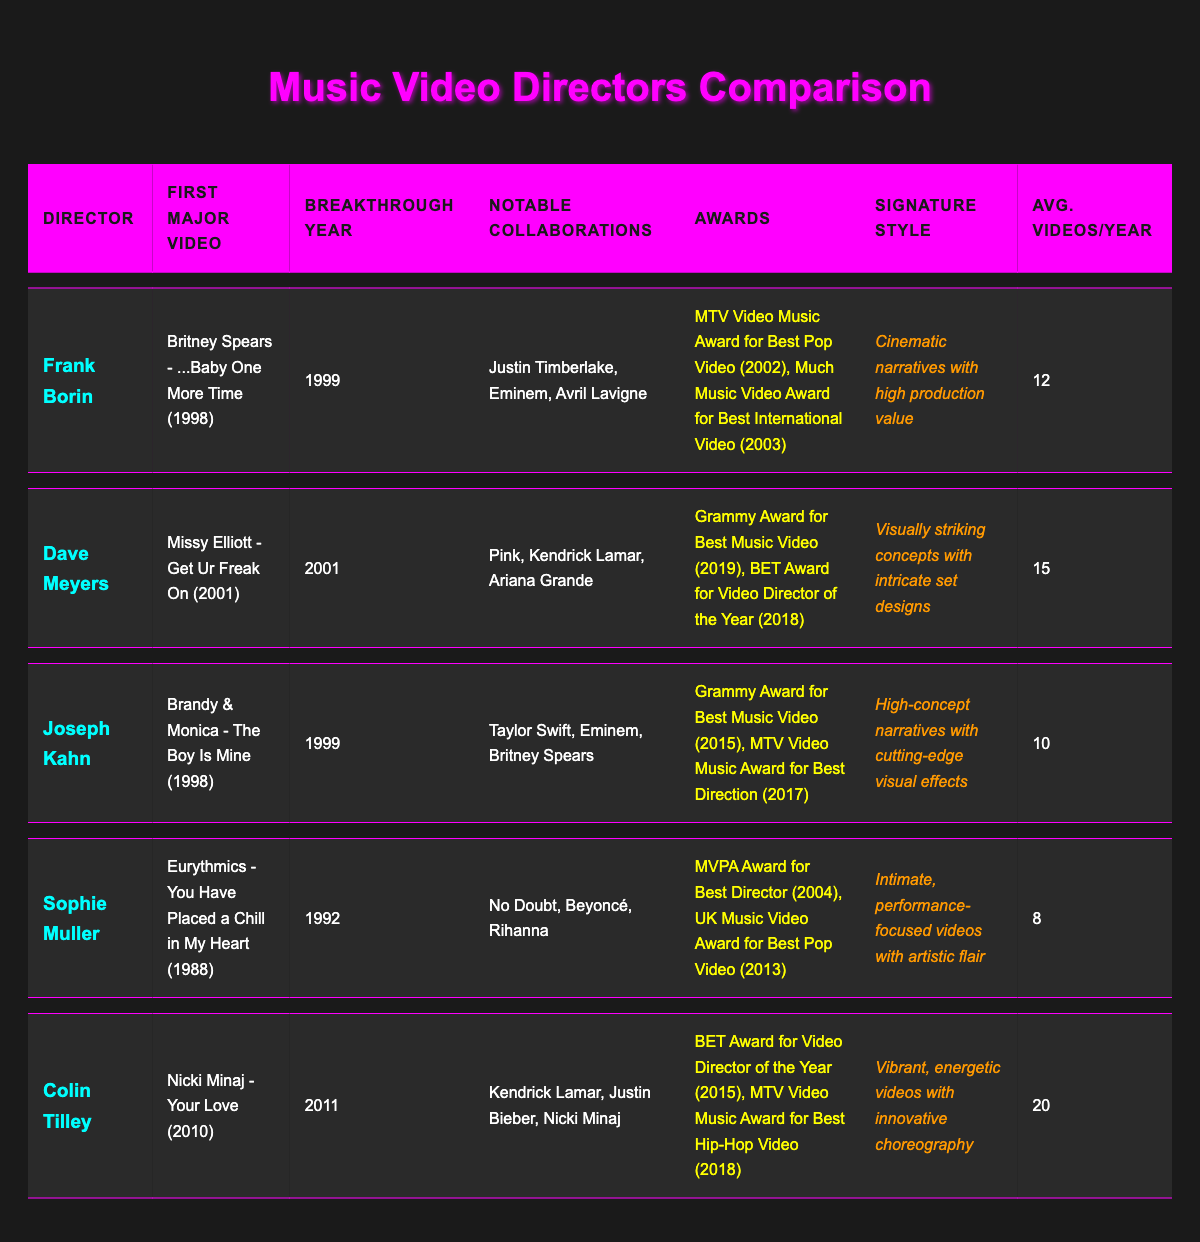What was Frank Borin's first major video? Frank Borin's first major video is listed in the table under the "First Major Video" column, which states "Britney Spears - ...Baby One More Time (1998)."
Answer: Britney Spears - ...Baby One More Time (1998) Which director has the highest average videos per year? By comparing the "Avg. Videos/Year" column, Colin Tilley has the highest average with 20 videos per year, as indicated in the table.
Answer: Colin Tilley Did Joseph Kahn win an award for Best Music Video? Looking at the "Awards" column for Joseph Kahn, it states he won the "Grammy Award for Best Music Video (2015)," which confirms he did win an award for Best Music Video.
Answer: Yes What is the total number of awards won by Sophie Muller and Dave Meyers combined? Sophie Muller has 2 awards listed, while Dave Meyers also has 2 awards. Adding them together gives a total of 2 + 2 = 4.
Answer: 4 Which director had their breakthrough year in 2011, and what is their signature style? The table shows Colin Tilley had his breakthrough year in 2011, and his signature style listed is "Vibrant, energetic videos with innovative choreography."
Answer: Colin Tilley; Vibrant, energetic videos with innovative choreography In what year did Frank Borin achieve his breakthrough, and how does it compare to Joseph Kahn's breakthrough year? Frank Borin's breakthrough year is 1999, while Joseph Kahn's is also 1999. Both directors broke through in the same year.
Answer: 1999; same year Is Sophie Muller known for collaborations with Rihanna? The table entries show that Sophie Muller has collaborated with "No Doubt, Beyoncé, Rihanna," confirming that she is known for collaborations with Rihanna.
Answer: Yes Calculate the average number of videos per year for all directors listed. The average is calculated by summing the average videos per year of all directors: (12 + 15 + 10 + 8 + 20) / 5 = 65 / 5 = 13.
Answer: 13 